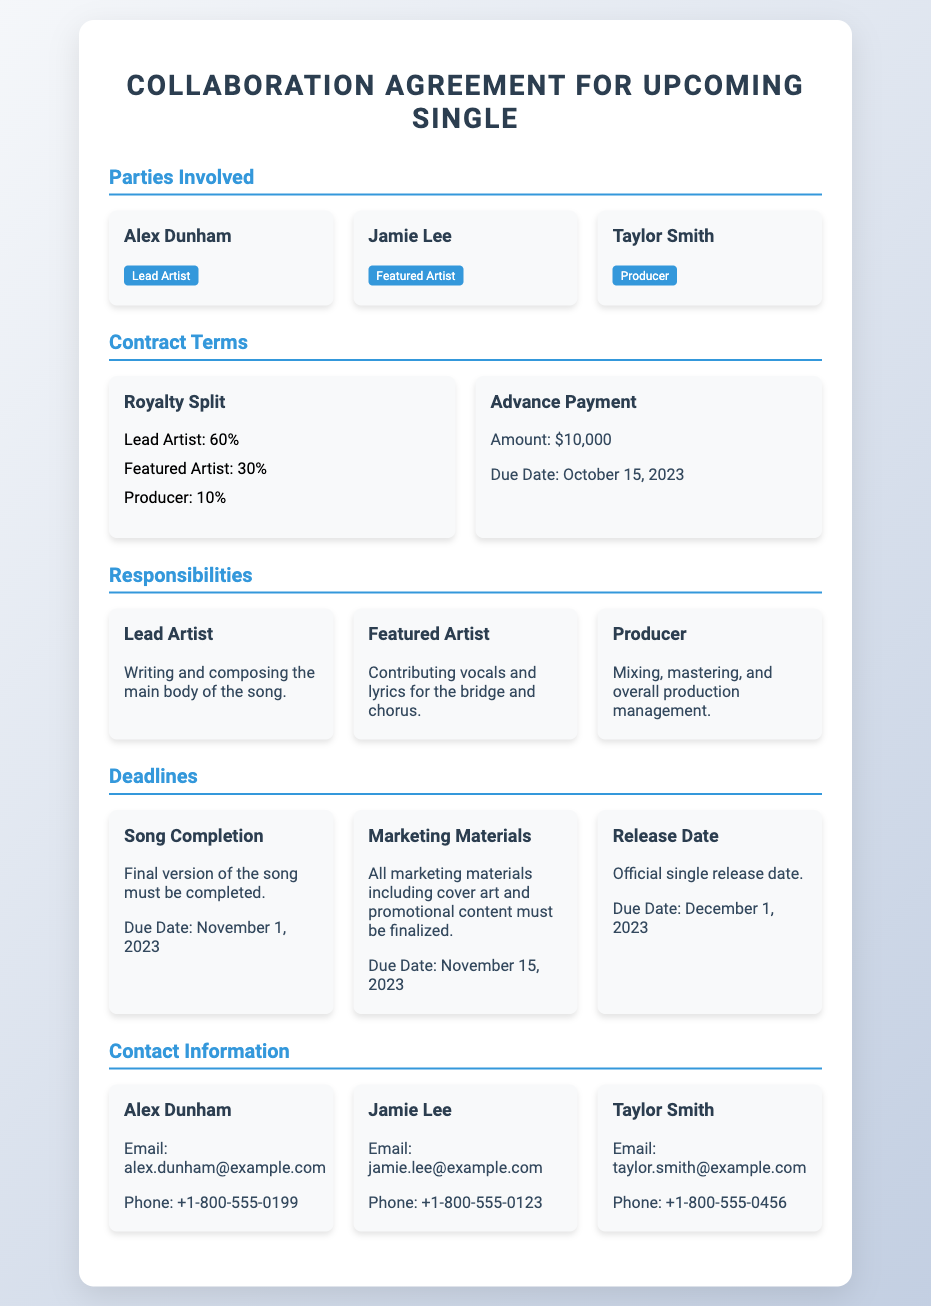What is the lead artist's name? The lead artist's name, as listed in the document, is Alex Dunham.
Answer: Alex Dunham What is the advance payment amount? The document states that the advance payment amount is $10,000.
Answer: $10,000 What percentage of royalties does the featured artist receive? The document indicates that the featured artist receives 30% of the royalties.
Answer: 30% When is the final version of the song due? According to the document, the final version of the song must be completed by November 1, 2023.
Answer: November 1, 2023 Who is responsible for mixing and mastering? The document specifies that the producer, Taylor Smith, is responsible for mixing and mastering.
Answer: Taylor Smith What is the release date for the single? The document notes that the official single release date is December 1, 2023.
Answer: December 1, 2023 What is included in the marketing materials? The document mentions that cover art and promotional content must be finalized as part of the marketing materials.
Answer: Cover art and promotional content What is the due date for marketing materials? The document states that the marketing materials are due by November 15, 2023.
Answer: November 15, 2023 What role does Jamie Lee have in the collaboration? The document describes Jamie Lee's role as the featured artist in the collaboration.
Answer: Featured Artist 